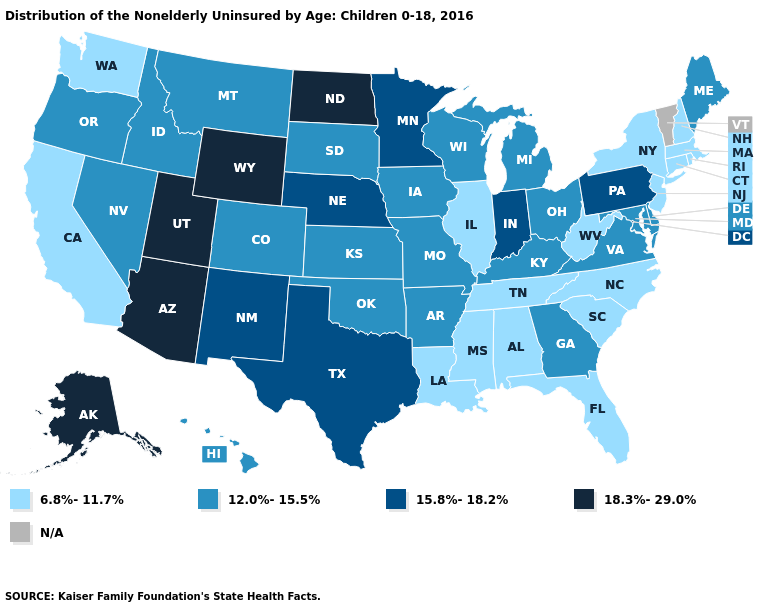Does Minnesota have the highest value in the MidWest?
Quick response, please. No. How many symbols are there in the legend?
Give a very brief answer. 5. What is the highest value in states that border Colorado?
Be succinct. 18.3%-29.0%. How many symbols are there in the legend?
Short answer required. 5. Name the states that have a value in the range 12.0%-15.5%?
Keep it brief. Arkansas, Colorado, Delaware, Georgia, Hawaii, Idaho, Iowa, Kansas, Kentucky, Maine, Maryland, Michigan, Missouri, Montana, Nevada, Ohio, Oklahoma, Oregon, South Dakota, Virginia, Wisconsin. Which states hav the highest value in the South?
Keep it brief. Texas. Which states have the highest value in the USA?
Write a very short answer. Alaska, Arizona, North Dakota, Utah, Wyoming. What is the value of Michigan?
Be succinct. 12.0%-15.5%. What is the lowest value in the South?
Be succinct. 6.8%-11.7%. What is the value of Wisconsin?
Give a very brief answer. 12.0%-15.5%. Name the states that have a value in the range 12.0%-15.5%?
Concise answer only. Arkansas, Colorado, Delaware, Georgia, Hawaii, Idaho, Iowa, Kansas, Kentucky, Maine, Maryland, Michigan, Missouri, Montana, Nevada, Ohio, Oklahoma, Oregon, South Dakota, Virginia, Wisconsin. Name the states that have a value in the range N/A?
Concise answer only. Vermont. Does Washington have the lowest value in the West?
Quick response, please. Yes. 